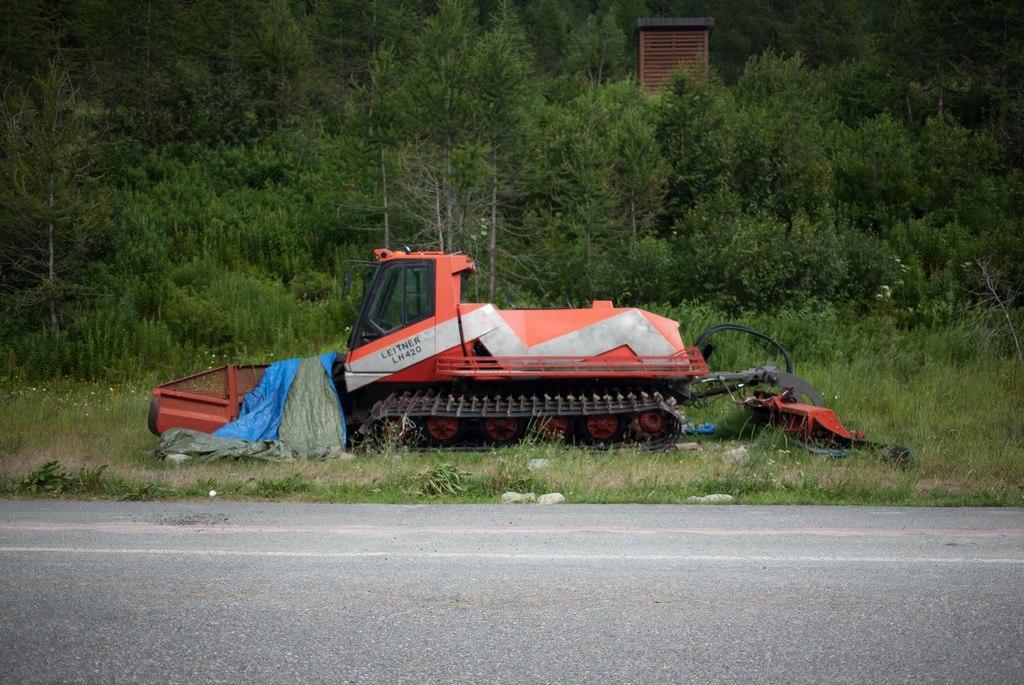Describe this image in one or two sentences. This picture is clicked outside. In the center we can see a vehicle seems to be a crane and we can see the grass, concrete road, plants, trees and some other objects. 